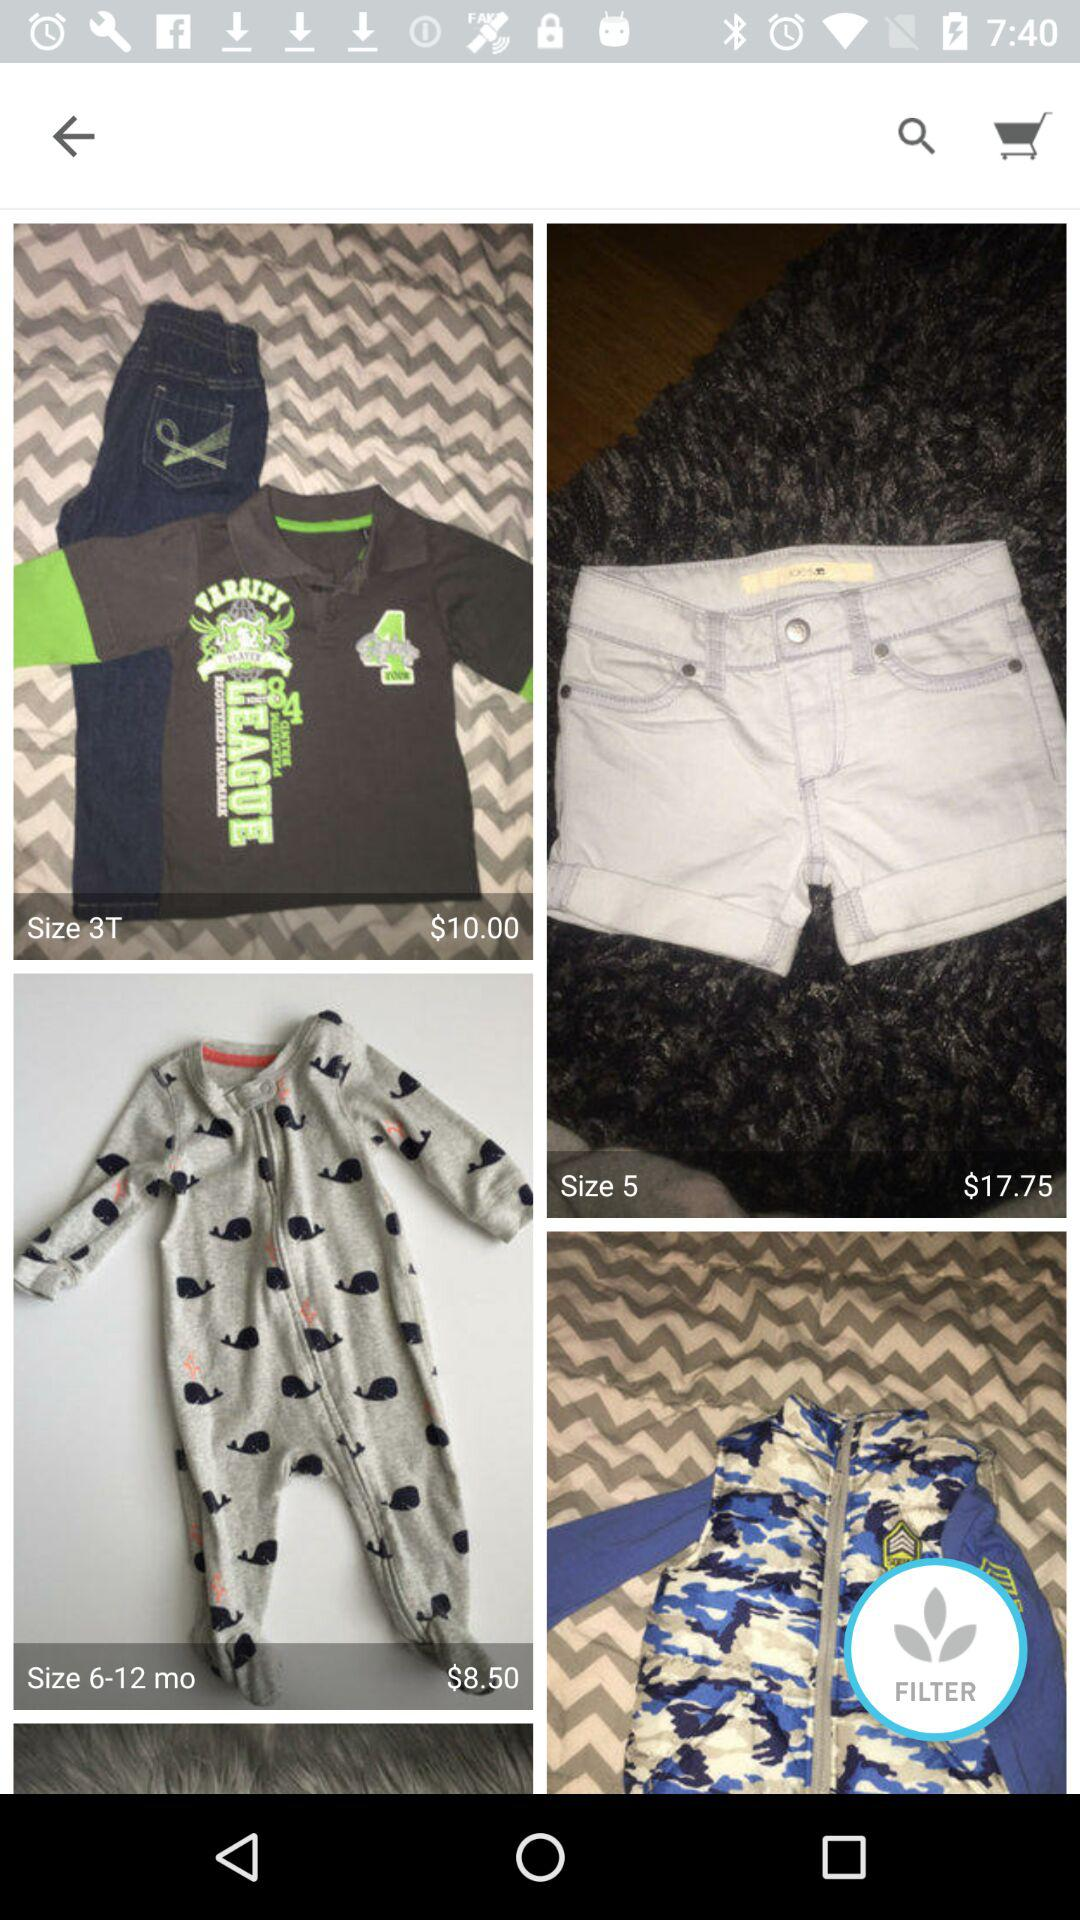How many items have a size that is 3T or 6-12 mo?
Answer the question using a single word or phrase. 2 